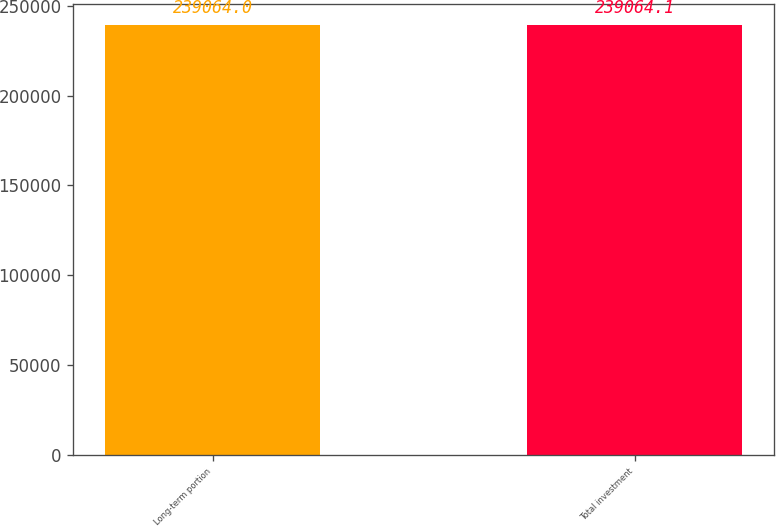Convert chart. <chart><loc_0><loc_0><loc_500><loc_500><bar_chart><fcel>Long-term portion<fcel>Total investment<nl><fcel>239064<fcel>239064<nl></chart> 